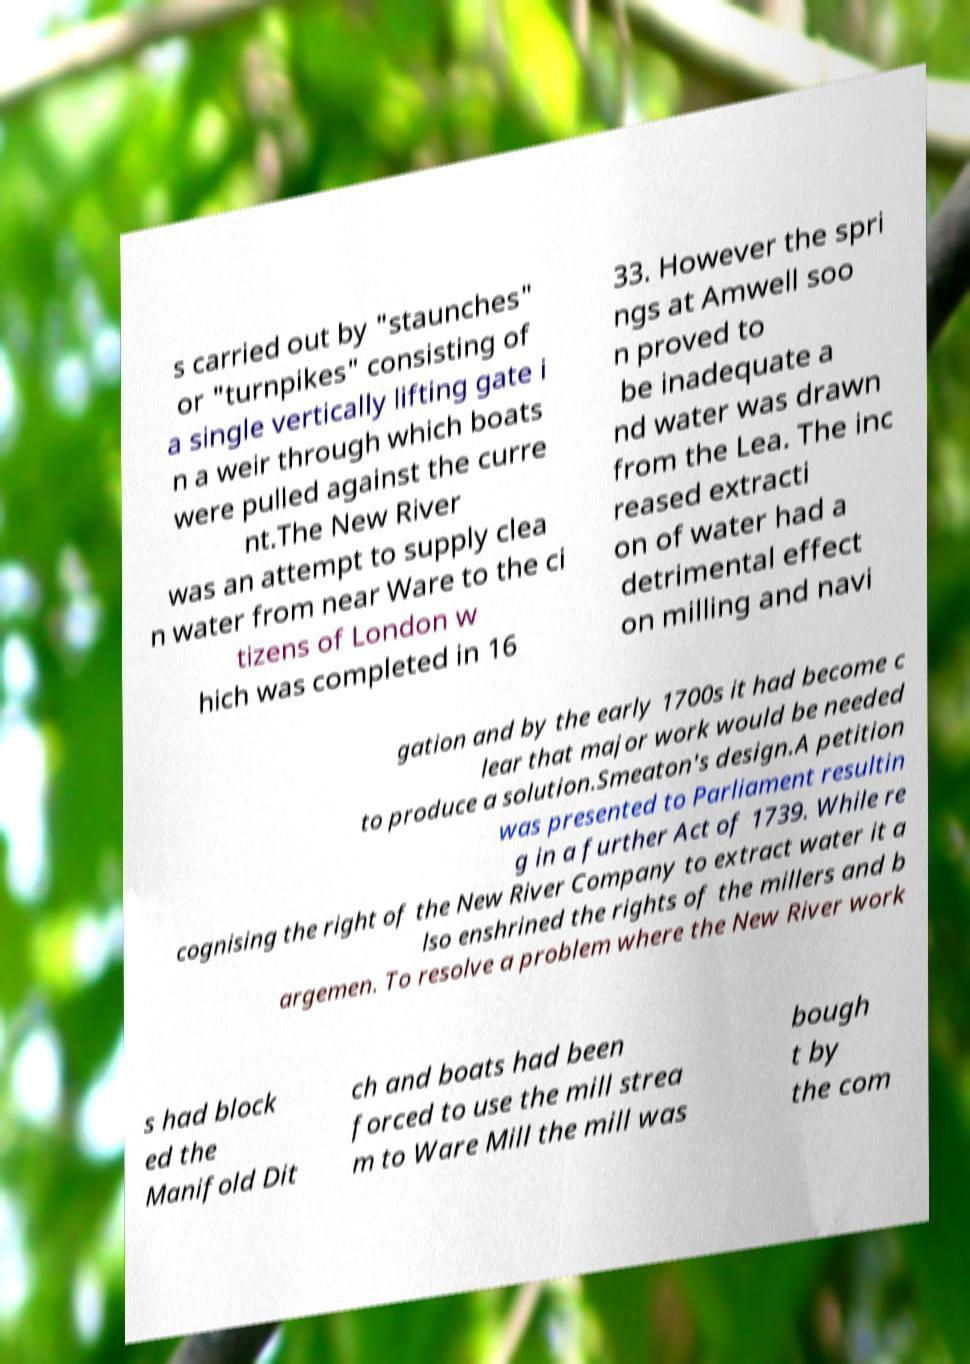Can you read and provide the text displayed in the image?This photo seems to have some interesting text. Can you extract and type it out for me? s carried out by "staunches" or "turnpikes" consisting of a single vertically lifting gate i n a weir through which boats were pulled against the curre nt.The New River was an attempt to supply clea n water from near Ware to the ci tizens of London w hich was completed in 16 33. However the spri ngs at Amwell soo n proved to be inadequate a nd water was drawn from the Lea. The inc reased extracti on of water had a detrimental effect on milling and navi gation and by the early 1700s it had become c lear that major work would be needed to produce a solution.Smeaton's design.A petition was presented to Parliament resultin g in a further Act of 1739. While re cognising the right of the New River Company to extract water it a lso enshrined the rights of the millers and b argemen. To resolve a problem where the New River work s had block ed the Manifold Dit ch and boats had been forced to use the mill strea m to Ware Mill the mill was bough t by the com 